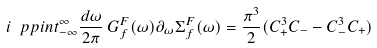Convert formula to latex. <formula><loc_0><loc_0><loc_500><loc_500>i \ p p i n t _ { - \infty } ^ { \infty } \frac { d \omega } { 2 \pi } \, G _ { f } ^ { F } ( \omega ) \partial _ { \omega } \Sigma _ { f } ^ { F } ( \omega ) = \frac { \pi ^ { 3 } } { 2 } ( C _ { + } ^ { 3 } C _ { - } - C _ { - } ^ { 3 } C _ { + } )</formula> 